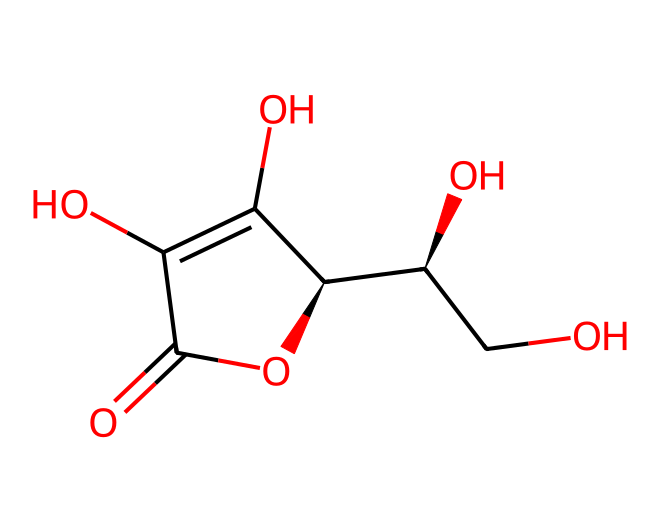What is the molecular formula of this structure? To find the molecular formula, count each type of atom in the structure. The structure contains 6 carbon atoms, 8 hydrogen atoms, and 6 oxygen atoms, which gives the formula C6H8O6.
Answer: C6H8O6 How many hydroxyl (–OH) groups are present? By examining the structure, we can identify the hydroxyl groups. There are three distinct –OH groups in the molecular layout.
Answer: three What type of functional groups are indicated in this molecule? Upon analyzing the structure, we can identify the presence of hydroxyl groups and a lactone (cyclic ester) due to the cyclic arrangement of the atoms, which are key features of vitamin C.
Answer: hydroxyl and lactone Is this molecule an acid or a base? Based on the presence of multiple hydroxyl groups and its overall molecular structure, it behaves predominantly as an acid in solution due to its ability to donate protons (H+).
Answer: acid What is the total number of rings in this molecule? By closely inspecting the structure, it's evident that there is one cyclic structure formed, confirming the presence of one ring.
Answer: one 